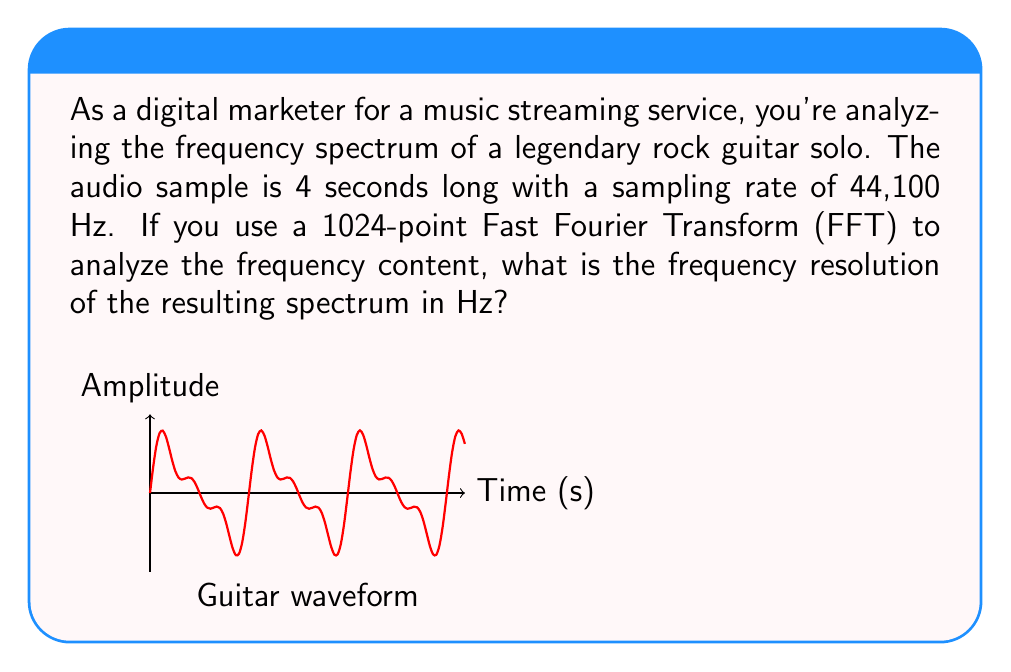Show me your answer to this math problem. Let's approach this step-by-step:

1) The frequency resolution (Δf) in an FFT is given by the formula:

   $$\Delta f = \frac{f_s}{N}$$

   Where $f_s$ is the sampling frequency and $N$ is the number of points in the FFT.

2) We are given:
   - Sampling rate (fs) = 44,100 Hz
   - Number of FFT points (N) = 1024

3) Substituting these values into the formula:

   $$\Delta f = \frac{44,100}{1024}$$

4) Calculating:

   $$\Delta f = 43.066406250 \text{ Hz}$$

5) Rounding to two decimal places for practicality:

   $$\Delta f \approx 43.07 \text{ Hz}$$

This means that each bin in the resulting frequency spectrum represents a bandwidth of approximately 43.07 Hz.
Answer: 43.07 Hz 